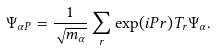Convert formula to latex. <formula><loc_0><loc_0><loc_500><loc_500>\Psi _ { \alpha { P } } = \frac { 1 } { \sqrt { m _ { \alpha } } } \sum _ { r } \exp ( i { P } { r } ) T _ { r } \Psi _ { \alpha } .</formula> 